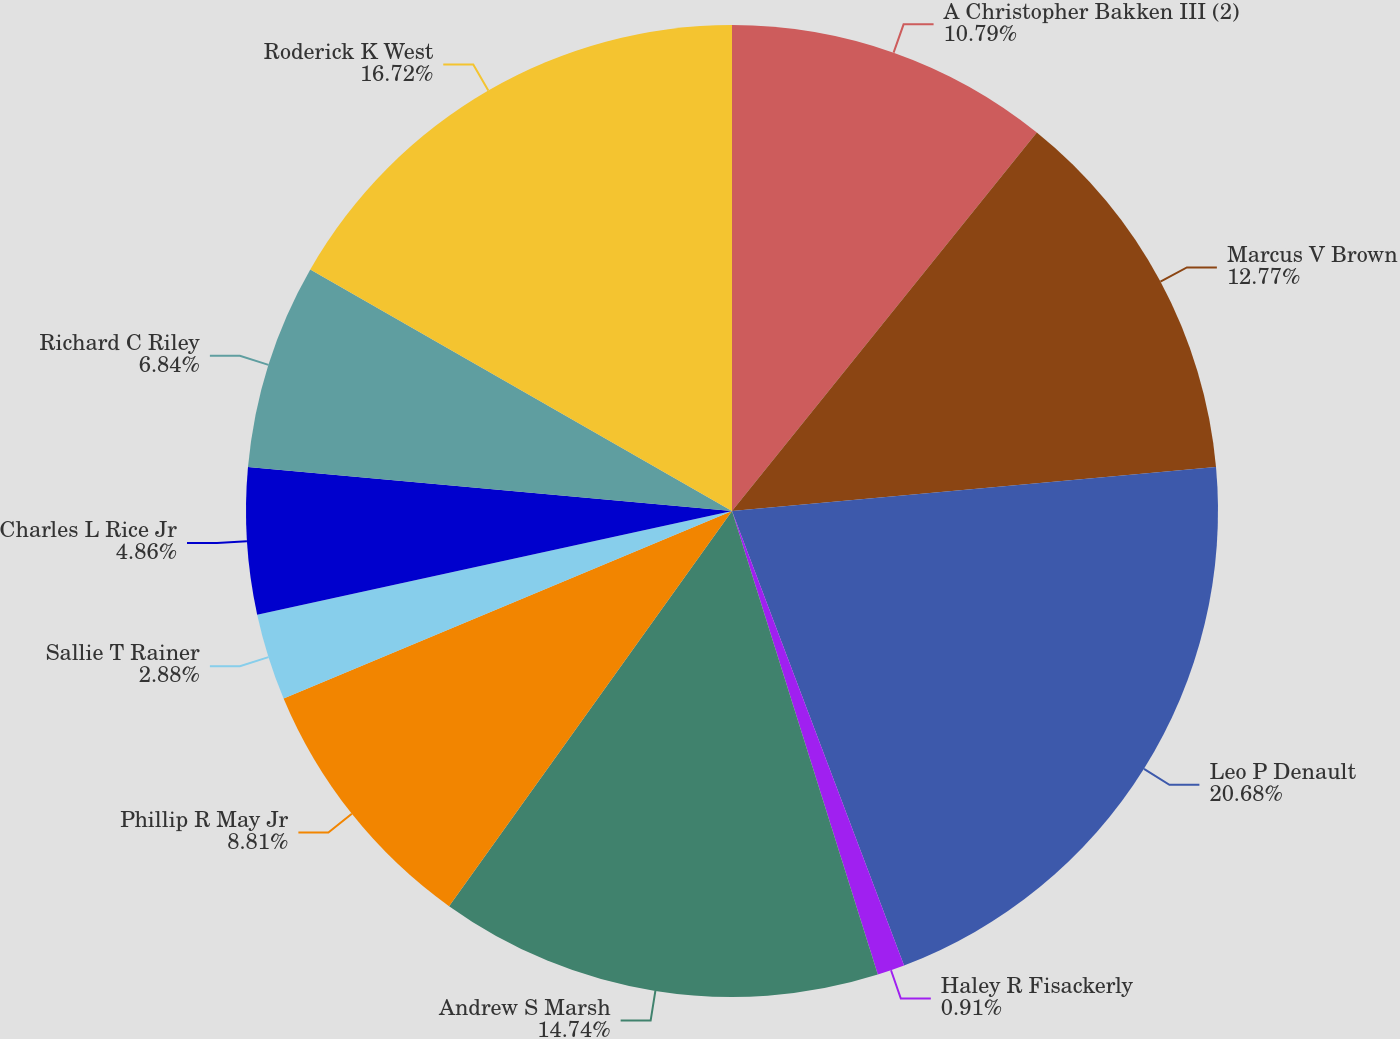Convert chart. <chart><loc_0><loc_0><loc_500><loc_500><pie_chart><fcel>A Christopher Bakken III (2)<fcel>Marcus V Brown<fcel>Leo P Denault<fcel>Haley R Fisackerly<fcel>Andrew S Marsh<fcel>Phillip R May Jr<fcel>Sallie T Rainer<fcel>Charles L Rice Jr<fcel>Richard C Riley<fcel>Roderick K West<nl><fcel>10.79%<fcel>12.77%<fcel>20.68%<fcel>0.91%<fcel>14.74%<fcel>8.81%<fcel>2.88%<fcel>4.86%<fcel>6.84%<fcel>16.72%<nl></chart> 